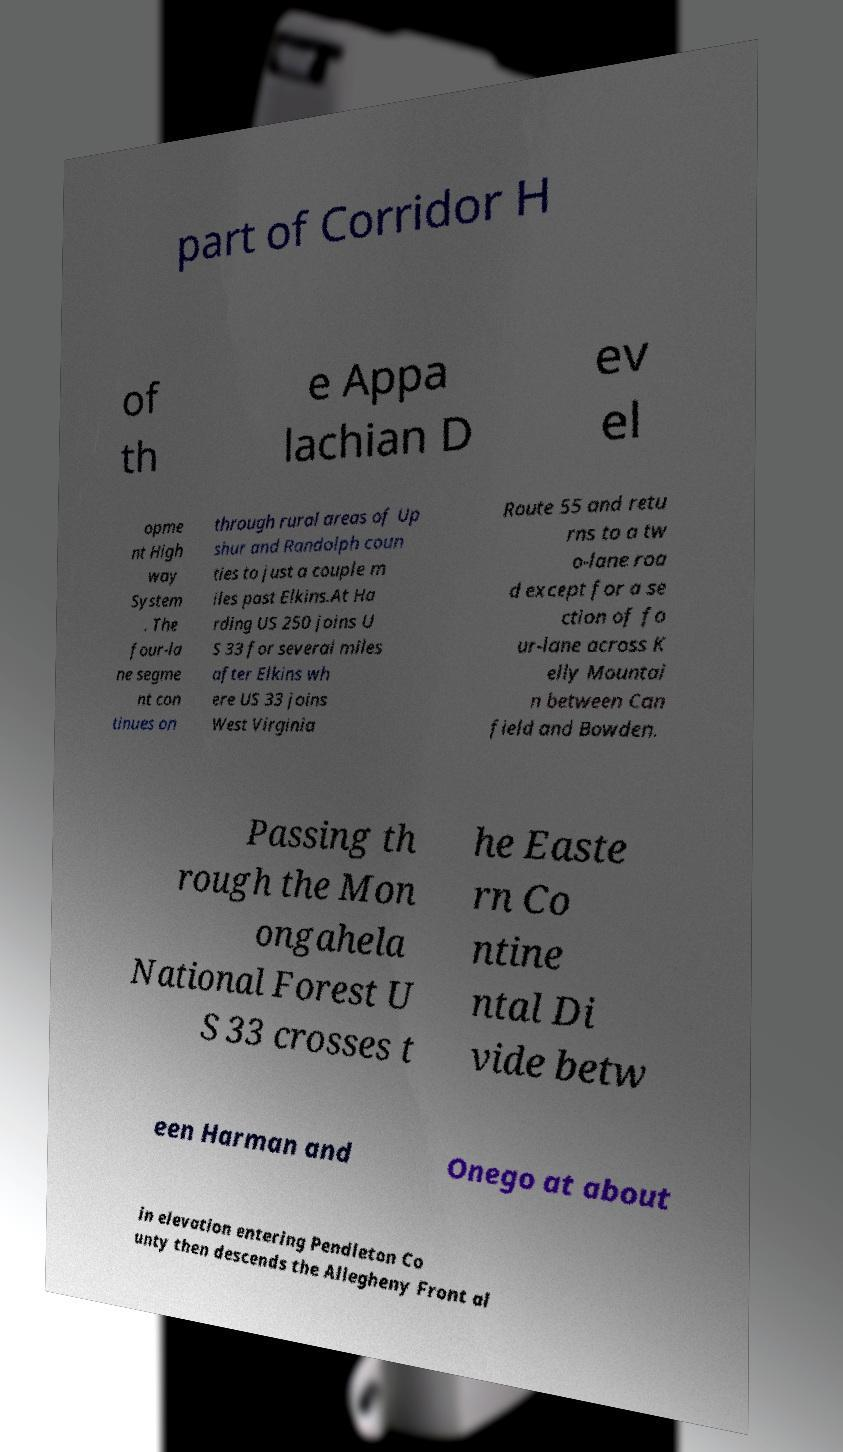Can you accurately transcribe the text from the provided image for me? part of Corridor H of th e Appa lachian D ev el opme nt High way System . The four-la ne segme nt con tinues on through rural areas of Up shur and Randolph coun ties to just a couple m iles past Elkins.At Ha rding US 250 joins U S 33 for several miles after Elkins wh ere US 33 joins West Virginia Route 55 and retu rns to a tw o-lane roa d except for a se ction of fo ur-lane across K elly Mountai n between Can field and Bowden. Passing th rough the Mon ongahela National Forest U S 33 crosses t he Easte rn Co ntine ntal Di vide betw een Harman and Onego at about in elevation entering Pendleton Co unty then descends the Allegheny Front al 